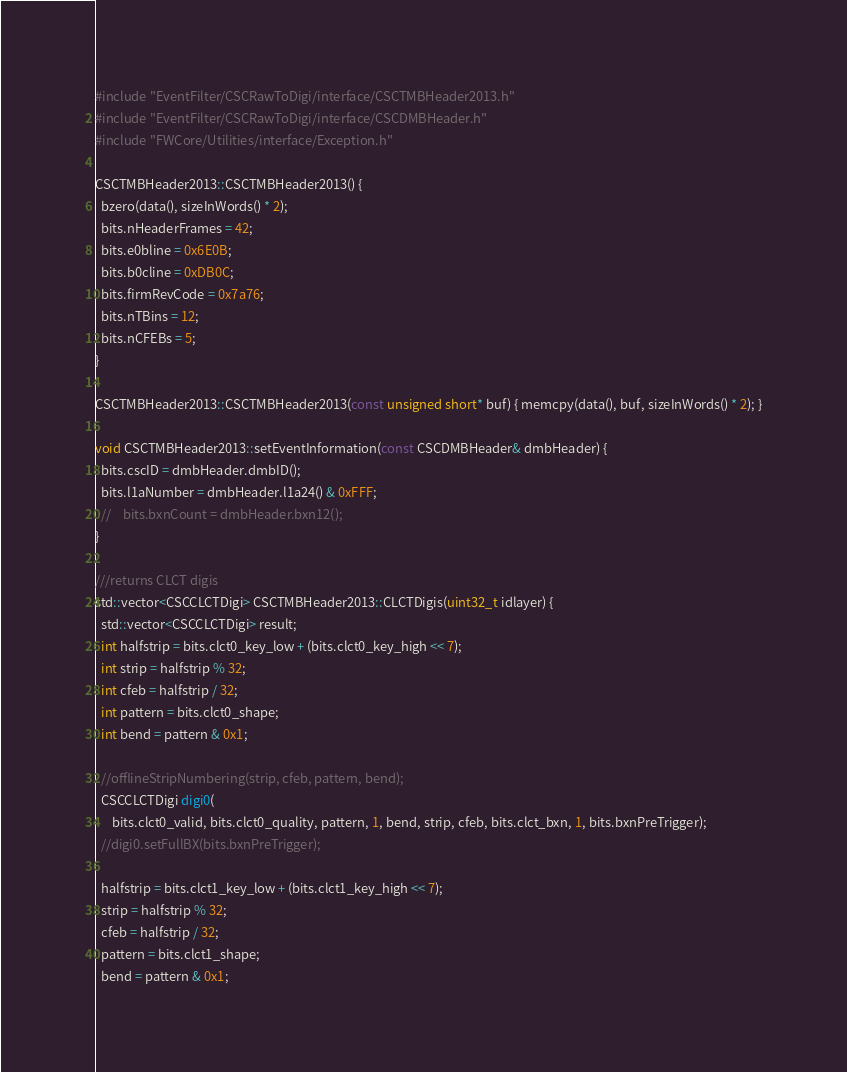Convert code to text. <code><loc_0><loc_0><loc_500><loc_500><_C++_>#include "EventFilter/CSCRawToDigi/interface/CSCTMBHeader2013.h"
#include "EventFilter/CSCRawToDigi/interface/CSCDMBHeader.h"
#include "FWCore/Utilities/interface/Exception.h"

CSCTMBHeader2013::CSCTMBHeader2013() {
  bzero(data(), sizeInWords() * 2);
  bits.nHeaderFrames = 42;
  bits.e0bline = 0x6E0B;
  bits.b0cline = 0xDB0C;
  bits.firmRevCode = 0x7a76;
  bits.nTBins = 12;
  bits.nCFEBs = 5;
}

CSCTMBHeader2013::CSCTMBHeader2013(const unsigned short* buf) { memcpy(data(), buf, sizeInWords() * 2); }

void CSCTMBHeader2013::setEventInformation(const CSCDMBHeader& dmbHeader) {
  bits.cscID = dmbHeader.dmbID();
  bits.l1aNumber = dmbHeader.l1a24() & 0xFFF;
  //    bits.bxnCount = dmbHeader.bxn12();
}

///returns CLCT digis
std::vector<CSCCLCTDigi> CSCTMBHeader2013::CLCTDigis(uint32_t idlayer) {
  std::vector<CSCCLCTDigi> result;
  int halfstrip = bits.clct0_key_low + (bits.clct0_key_high << 7);
  int strip = halfstrip % 32;
  int cfeb = halfstrip / 32;
  int pattern = bits.clct0_shape;
  int bend = pattern & 0x1;

  //offlineStripNumbering(strip, cfeb, pattern, bend);
  CSCCLCTDigi digi0(
      bits.clct0_valid, bits.clct0_quality, pattern, 1, bend, strip, cfeb, bits.clct_bxn, 1, bits.bxnPreTrigger);
  //digi0.setFullBX(bits.bxnPreTrigger);

  halfstrip = bits.clct1_key_low + (bits.clct1_key_high << 7);
  strip = halfstrip % 32;
  cfeb = halfstrip / 32;
  pattern = bits.clct1_shape;
  bend = pattern & 0x1;
</code> 